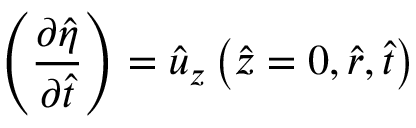Convert formula to latex. <formula><loc_0><loc_0><loc_500><loc_500>\left ( \frac { \partial \hat { \eta } } { \partial \hat { t } } \right ) = \hat { u } _ { z } \left ( \hat { z } = 0 , \hat { r } , \hat { t } \right )</formula> 